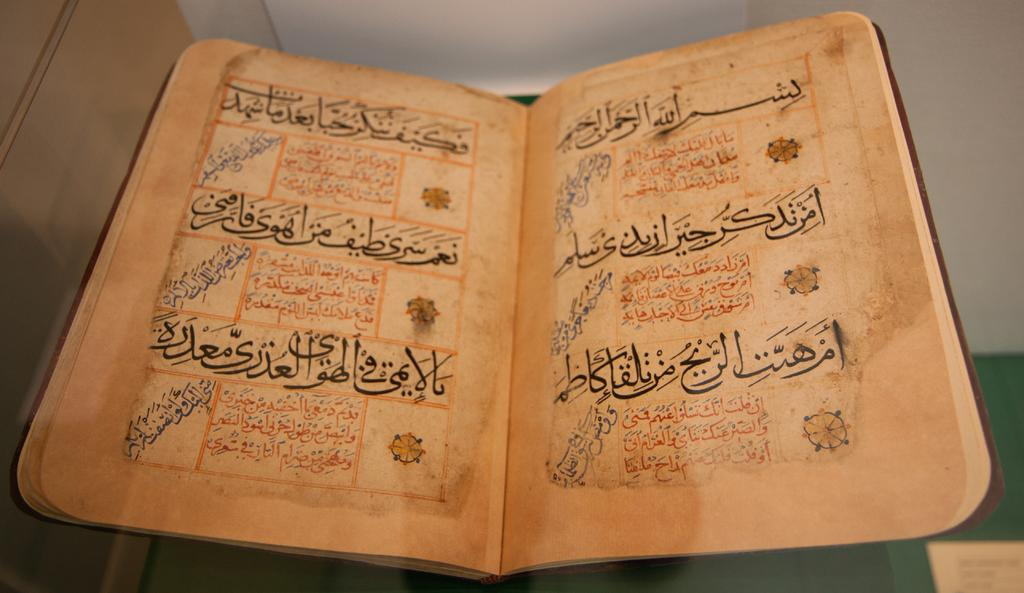Provide a one-sentence caption for the provided image. A book is open with text all in Arabic. 